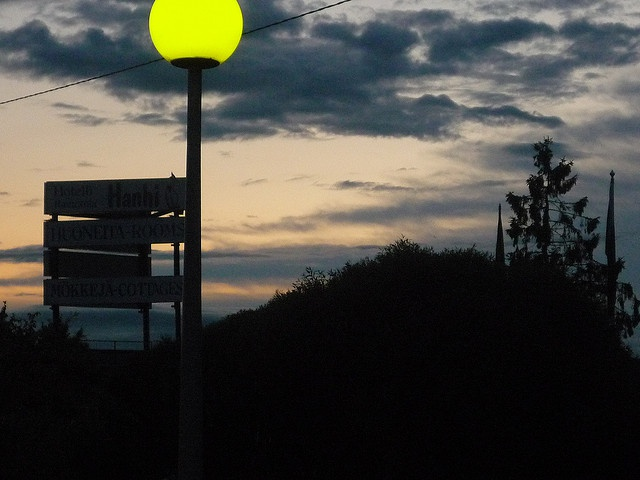Describe the objects in this image and their specific colors. I can see various objects in this image with different colors. 